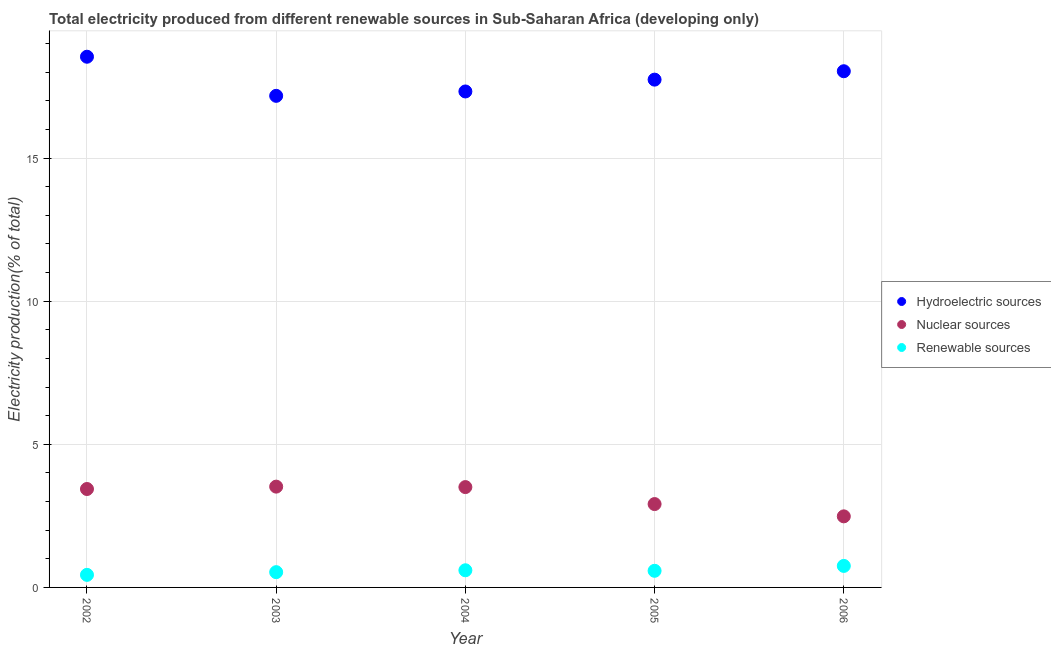What is the percentage of electricity produced by hydroelectric sources in 2005?
Offer a terse response. 17.74. Across all years, what is the maximum percentage of electricity produced by renewable sources?
Provide a succinct answer. 0.75. Across all years, what is the minimum percentage of electricity produced by nuclear sources?
Your answer should be very brief. 2.48. What is the total percentage of electricity produced by hydroelectric sources in the graph?
Keep it short and to the point. 88.81. What is the difference between the percentage of electricity produced by nuclear sources in 2002 and that in 2003?
Provide a short and direct response. -0.08. What is the difference between the percentage of electricity produced by nuclear sources in 2003 and the percentage of electricity produced by renewable sources in 2005?
Offer a very short reply. 2.94. What is the average percentage of electricity produced by hydroelectric sources per year?
Offer a very short reply. 17.76. In the year 2002, what is the difference between the percentage of electricity produced by nuclear sources and percentage of electricity produced by hydroelectric sources?
Offer a very short reply. -15.1. In how many years, is the percentage of electricity produced by renewable sources greater than 7 %?
Keep it short and to the point. 0. What is the ratio of the percentage of electricity produced by renewable sources in 2002 to that in 2006?
Give a very brief answer. 0.58. Is the percentage of electricity produced by renewable sources in 2005 less than that in 2006?
Provide a succinct answer. Yes. What is the difference between the highest and the second highest percentage of electricity produced by renewable sources?
Keep it short and to the point. 0.15. What is the difference between the highest and the lowest percentage of electricity produced by hydroelectric sources?
Ensure brevity in your answer.  1.37. In how many years, is the percentage of electricity produced by hydroelectric sources greater than the average percentage of electricity produced by hydroelectric sources taken over all years?
Ensure brevity in your answer.  2. Is the percentage of electricity produced by hydroelectric sources strictly less than the percentage of electricity produced by renewable sources over the years?
Your answer should be compact. No. How many dotlines are there?
Offer a terse response. 3. What is the difference between two consecutive major ticks on the Y-axis?
Your response must be concise. 5. Does the graph contain any zero values?
Make the answer very short. No. Does the graph contain grids?
Your answer should be compact. Yes. How many legend labels are there?
Offer a very short reply. 3. How are the legend labels stacked?
Provide a succinct answer. Vertical. What is the title of the graph?
Provide a succinct answer. Total electricity produced from different renewable sources in Sub-Saharan Africa (developing only). Does "Food" appear as one of the legend labels in the graph?
Your answer should be compact. No. What is the Electricity production(% of total) of Hydroelectric sources in 2002?
Give a very brief answer. 18.54. What is the Electricity production(% of total) in Nuclear sources in 2002?
Keep it short and to the point. 3.44. What is the Electricity production(% of total) of Renewable sources in 2002?
Give a very brief answer. 0.44. What is the Electricity production(% of total) of Hydroelectric sources in 2003?
Your answer should be very brief. 17.17. What is the Electricity production(% of total) of Nuclear sources in 2003?
Give a very brief answer. 3.52. What is the Electricity production(% of total) in Renewable sources in 2003?
Your response must be concise. 0.53. What is the Electricity production(% of total) of Hydroelectric sources in 2004?
Provide a short and direct response. 17.33. What is the Electricity production(% of total) in Nuclear sources in 2004?
Offer a very short reply. 3.51. What is the Electricity production(% of total) of Renewable sources in 2004?
Your answer should be compact. 0.6. What is the Electricity production(% of total) in Hydroelectric sources in 2005?
Your answer should be very brief. 17.74. What is the Electricity production(% of total) of Nuclear sources in 2005?
Your answer should be compact. 2.91. What is the Electricity production(% of total) in Renewable sources in 2005?
Make the answer very short. 0.58. What is the Electricity production(% of total) in Hydroelectric sources in 2006?
Ensure brevity in your answer.  18.03. What is the Electricity production(% of total) of Nuclear sources in 2006?
Your response must be concise. 2.48. What is the Electricity production(% of total) in Renewable sources in 2006?
Provide a succinct answer. 0.75. Across all years, what is the maximum Electricity production(% of total) in Hydroelectric sources?
Provide a short and direct response. 18.54. Across all years, what is the maximum Electricity production(% of total) of Nuclear sources?
Offer a terse response. 3.52. Across all years, what is the maximum Electricity production(% of total) in Renewable sources?
Give a very brief answer. 0.75. Across all years, what is the minimum Electricity production(% of total) in Hydroelectric sources?
Offer a terse response. 17.17. Across all years, what is the minimum Electricity production(% of total) in Nuclear sources?
Make the answer very short. 2.48. Across all years, what is the minimum Electricity production(% of total) in Renewable sources?
Your response must be concise. 0.44. What is the total Electricity production(% of total) of Hydroelectric sources in the graph?
Keep it short and to the point. 88.81. What is the total Electricity production(% of total) in Nuclear sources in the graph?
Make the answer very short. 15.86. What is the total Electricity production(% of total) of Renewable sources in the graph?
Provide a succinct answer. 2.9. What is the difference between the Electricity production(% of total) in Hydroelectric sources in 2002 and that in 2003?
Provide a succinct answer. 1.37. What is the difference between the Electricity production(% of total) of Nuclear sources in 2002 and that in 2003?
Provide a short and direct response. -0.08. What is the difference between the Electricity production(% of total) of Renewable sources in 2002 and that in 2003?
Give a very brief answer. -0.09. What is the difference between the Electricity production(% of total) in Hydroelectric sources in 2002 and that in 2004?
Make the answer very short. 1.21. What is the difference between the Electricity production(% of total) of Nuclear sources in 2002 and that in 2004?
Provide a succinct answer. -0.07. What is the difference between the Electricity production(% of total) of Renewable sources in 2002 and that in 2004?
Provide a short and direct response. -0.16. What is the difference between the Electricity production(% of total) in Hydroelectric sources in 2002 and that in 2005?
Offer a very short reply. 0.8. What is the difference between the Electricity production(% of total) in Nuclear sources in 2002 and that in 2005?
Give a very brief answer. 0.53. What is the difference between the Electricity production(% of total) of Renewable sources in 2002 and that in 2005?
Offer a terse response. -0.14. What is the difference between the Electricity production(% of total) in Hydroelectric sources in 2002 and that in 2006?
Offer a terse response. 0.51. What is the difference between the Electricity production(% of total) in Nuclear sources in 2002 and that in 2006?
Provide a short and direct response. 0.96. What is the difference between the Electricity production(% of total) in Renewable sources in 2002 and that in 2006?
Keep it short and to the point. -0.31. What is the difference between the Electricity production(% of total) in Hydroelectric sources in 2003 and that in 2004?
Keep it short and to the point. -0.15. What is the difference between the Electricity production(% of total) of Nuclear sources in 2003 and that in 2004?
Ensure brevity in your answer.  0.02. What is the difference between the Electricity production(% of total) in Renewable sources in 2003 and that in 2004?
Provide a succinct answer. -0.07. What is the difference between the Electricity production(% of total) in Hydroelectric sources in 2003 and that in 2005?
Keep it short and to the point. -0.57. What is the difference between the Electricity production(% of total) in Nuclear sources in 2003 and that in 2005?
Your answer should be very brief. 0.61. What is the difference between the Electricity production(% of total) in Renewable sources in 2003 and that in 2005?
Keep it short and to the point. -0.05. What is the difference between the Electricity production(% of total) in Hydroelectric sources in 2003 and that in 2006?
Provide a succinct answer. -0.86. What is the difference between the Electricity production(% of total) of Nuclear sources in 2003 and that in 2006?
Your response must be concise. 1.04. What is the difference between the Electricity production(% of total) in Renewable sources in 2003 and that in 2006?
Offer a very short reply. -0.22. What is the difference between the Electricity production(% of total) in Hydroelectric sources in 2004 and that in 2005?
Keep it short and to the point. -0.41. What is the difference between the Electricity production(% of total) of Nuclear sources in 2004 and that in 2005?
Your answer should be compact. 0.59. What is the difference between the Electricity production(% of total) in Renewable sources in 2004 and that in 2005?
Your answer should be compact. 0.02. What is the difference between the Electricity production(% of total) in Hydroelectric sources in 2004 and that in 2006?
Make the answer very short. -0.71. What is the difference between the Electricity production(% of total) of Nuclear sources in 2004 and that in 2006?
Offer a terse response. 1.02. What is the difference between the Electricity production(% of total) in Renewable sources in 2004 and that in 2006?
Ensure brevity in your answer.  -0.15. What is the difference between the Electricity production(% of total) of Hydroelectric sources in 2005 and that in 2006?
Make the answer very short. -0.29. What is the difference between the Electricity production(% of total) in Nuclear sources in 2005 and that in 2006?
Offer a very short reply. 0.43. What is the difference between the Electricity production(% of total) in Renewable sources in 2005 and that in 2006?
Offer a very short reply. -0.17. What is the difference between the Electricity production(% of total) of Hydroelectric sources in 2002 and the Electricity production(% of total) of Nuclear sources in 2003?
Offer a terse response. 15.02. What is the difference between the Electricity production(% of total) of Hydroelectric sources in 2002 and the Electricity production(% of total) of Renewable sources in 2003?
Your response must be concise. 18. What is the difference between the Electricity production(% of total) of Nuclear sources in 2002 and the Electricity production(% of total) of Renewable sources in 2003?
Your answer should be compact. 2.9. What is the difference between the Electricity production(% of total) in Hydroelectric sources in 2002 and the Electricity production(% of total) in Nuclear sources in 2004?
Offer a very short reply. 15.03. What is the difference between the Electricity production(% of total) in Hydroelectric sources in 2002 and the Electricity production(% of total) in Renewable sources in 2004?
Ensure brevity in your answer.  17.94. What is the difference between the Electricity production(% of total) of Nuclear sources in 2002 and the Electricity production(% of total) of Renewable sources in 2004?
Your answer should be compact. 2.84. What is the difference between the Electricity production(% of total) of Hydroelectric sources in 2002 and the Electricity production(% of total) of Nuclear sources in 2005?
Keep it short and to the point. 15.63. What is the difference between the Electricity production(% of total) of Hydroelectric sources in 2002 and the Electricity production(% of total) of Renewable sources in 2005?
Your response must be concise. 17.96. What is the difference between the Electricity production(% of total) in Nuclear sources in 2002 and the Electricity production(% of total) in Renewable sources in 2005?
Your response must be concise. 2.86. What is the difference between the Electricity production(% of total) in Hydroelectric sources in 2002 and the Electricity production(% of total) in Nuclear sources in 2006?
Your answer should be compact. 16.06. What is the difference between the Electricity production(% of total) of Hydroelectric sources in 2002 and the Electricity production(% of total) of Renewable sources in 2006?
Offer a terse response. 17.79. What is the difference between the Electricity production(% of total) of Nuclear sources in 2002 and the Electricity production(% of total) of Renewable sources in 2006?
Give a very brief answer. 2.69. What is the difference between the Electricity production(% of total) of Hydroelectric sources in 2003 and the Electricity production(% of total) of Nuclear sources in 2004?
Ensure brevity in your answer.  13.67. What is the difference between the Electricity production(% of total) in Hydroelectric sources in 2003 and the Electricity production(% of total) in Renewable sources in 2004?
Offer a terse response. 16.57. What is the difference between the Electricity production(% of total) in Nuclear sources in 2003 and the Electricity production(% of total) in Renewable sources in 2004?
Provide a short and direct response. 2.92. What is the difference between the Electricity production(% of total) of Hydroelectric sources in 2003 and the Electricity production(% of total) of Nuclear sources in 2005?
Give a very brief answer. 14.26. What is the difference between the Electricity production(% of total) in Hydroelectric sources in 2003 and the Electricity production(% of total) in Renewable sources in 2005?
Your response must be concise. 16.59. What is the difference between the Electricity production(% of total) of Nuclear sources in 2003 and the Electricity production(% of total) of Renewable sources in 2005?
Make the answer very short. 2.94. What is the difference between the Electricity production(% of total) of Hydroelectric sources in 2003 and the Electricity production(% of total) of Nuclear sources in 2006?
Provide a succinct answer. 14.69. What is the difference between the Electricity production(% of total) in Hydroelectric sources in 2003 and the Electricity production(% of total) in Renewable sources in 2006?
Offer a terse response. 16.42. What is the difference between the Electricity production(% of total) in Nuclear sources in 2003 and the Electricity production(% of total) in Renewable sources in 2006?
Provide a succinct answer. 2.77. What is the difference between the Electricity production(% of total) in Hydroelectric sources in 2004 and the Electricity production(% of total) in Nuclear sources in 2005?
Keep it short and to the point. 14.41. What is the difference between the Electricity production(% of total) in Hydroelectric sources in 2004 and the Electricity production(% of total) in Renewable sources in 2005?
Your answer should be very brief. 16.74. What is the difference between the Electricity production(% of total) in Nuclear sources in 2004 and the Electricity production(% of total) in Renewable sources in 2005?
Ensure brevity in your answer.  2.92. What is the difference between the Electricity production(% of total) in Hydroelectric sources in 2004 and the Electricity production(% of total) in Nuclear sources in 2006?
Provide a succinct answer. 14.84. What is the difference between the Electricity production(% of total) in Hydroelectric sources in 2004 and the Electricity production(% of total) in Renewable sources in 2006?
Provide a succinct answer. 16.57. What is the difference between the Electricity production(% of total) of Nuclear sources in 2004 and the Electricity production(% of total) of Renewable sources in 2006?
Offer a very short reply. 2.75. What is the difference between the Electricity production(% of total) in Hydroelectric sources in 2005 and the Electricity production(% of total) in Nuclear sources in 2006?
Provide a succinct answer. 15.26. What is the difference between the Electricity production(% of total) of Hydroelectric sources in 2005 and the Electricity production(% of total) of Renewable sources in 2006?
Your answer should be compact. 16.99. What is the difference between the Electricity production(% of total) of Nuclear sources in 2005 and the Electricity production(% of total) of Renewable sources in 2006?
Provide a short and direct response. 2.16. What is the average Electricity production(% of total) in Hydroelectric sources per year?
Your answer should be very brief. 17.76. What is the average Electricity production(% of total) in Nuclear sources per year?
Your answer should be compact. 3.17. What is the average Electricity production(% of total) of Renewable sources per year?
Keep it short and to the point. 0.58. In the year 2002, what is the difference between the Electricity production(% of total) in Hydroelectric sources and Electricity production(% of total) in Nuclear sources?
Give a very brief answer. 15.1. In the year 2002, what is the difference between the Electricity production(% of total) in Hydroelectric sources and Electricity production(% of total) in Renewable sources?
Provide a succinct answer. 18.1. In the year 2002, what is the difference between the Electricity production(% of total) of Nuclear sources and Electricity production(% of total) of Renewable sources?
Provide a short and direct response. 3. In the year 2003, what is the difference between the Electricity production(% of total) of Hydroelectric sources and Electricity production(% of total) of Nuclear sources?
Offer a very short reply. 13.65. In the year 2003, what is the difference between the Electricity production(% of total) in Hydroelectric sources and Electricity production(% of total) in Renewable sources?
Offer a terse response. 16.64. In the year 2003, what is the difference between the Electricity production(% of total) in Nuclear sources and Electricity production(% of total) in Renewable sources?
Offer a very short reply. 2.99. In the year 2004, what is the difference between the Electricity production(% of total) in Hydroelectric sources and Electricity production(% of total) in Nuclear sources?
Your response must be concise. 13.82. In the year 2004, what is the difference between the Electricity production(% of total) in Hydroelectric sources and Electricity production(% of total) in Renewable sources?
Your answer should be very brief. 16.73. In the year 2004, what is the difference between the Electricity production(% of total) in Nuclear sources and Electricity production(% of total) in Renewable sources?
Your answer should be very brief. 2.91. In the year 2005, what is the difference between the Electricity production(% of total) in Hydroelectric sources and Electricity production(% of total) in Nuclear sources?
Offer a very short reply. 14.83. In the year 2005, what is the difference between the Electricity production(% of total) of Hydroelectric sources and Electricity production(% of total) of Renewable sources?
Offer a very short reply. 17.16. In the year 2005, what is the difference between the Electricity production(% of total) of Nuclear sources and Electricity production(% of total) of Renewable sources?
Give a very brief answer. 2.33. In the year 2006, what is the difference between the Electricity production(% of total) in Hydroelectric sources and Electricity production(% of total) in Nuclear sources?
Provide a succinct answer. 15.55. In the year 2006, what is the difference between the Electricity production(% of total) of Hydroelectric sources and Electricity production(% of total) of Renewable sources?
Make the answer very short. 17.28. In the year 2006, what is the difference between the Electricity production(% of total) in Nuclear sources and Electricity production(% of total) in Renewable sources?
Keep it short and to the point. 1.73. What is the ratio of the Electricity production(% of total) of Hydroelectric sources in 2002 to that in 2003?
Provide a short and direct response. 1.08. What is the ratio of the Electricity production(% of total) of Nuclear sources in 2002 to that in 2003?
Offer a very short reply. 0.98. What is the ratio of the Electricity production(% of total) of Renewable sources in 2002 to that in 2003?
Your answer should be compact. 0.82. What is the ratio of the Electricity production(% of total) in Hydroelectric sources in 2002 to that in 2004?
Offer a very short reply. 1.07. What is the ratio of the Electricity production(% of total) of Nuclear sources in 2002 to that in 2004?
Offer a very short reply. 0.98. What is the ratio of the Electricity production(% of total) of Renewable sources in 2002 to that in 2004?
Your answer should be compact. 0.73. What is the ratio of the Electricity production(% of total) of Hydroelectric sources in 2002 to that in 2005?
Provide a short and direct response. 1.05. What is the ratio of the Electricity production(% of total) of Nuclear sources in 2002 to that in 2005?
Provide a short and direct response. 1.18. What is the ratio of the Electricity production(% of total) of Renewable sources in 2002 to that in 2005?
Offer a very short reply. 0.76. What is the ratio of the Electricity production(% of total) in Hydroelectric sources in 2002 to that in 2006?
Keep it short and to the point. 1.03. What is the ratio of the Electricity production(% of total) of Nuclear sources in 2002 to that in 2006?
Your answer should be very brief. 1.38. What is the ratio of the Electricity production(% of total) of Renewable sources in 2002 to that in 2006?
Offer a terse response. 0.58. What is the ratio of the Electricity production(% of total) of Hydroelectric sources in 2003 to that in 2004?
Offer a terse response. 0.99. What is the ratio of the Electricity production(% of total) in Nuclear sources in 2003 to that in 2004?
Keep it short and to the point. 1. What is the ratio of the Electricity production(% of total) of Renewable sources in 2003 to that in 2004?
Offer a very short reply. 0.89. What is the ratio of the Electricity production(% of total) in Hydroelectric sources in 2003 to that in 2005?
Provide a succinct answer. 0.97. What is the ratio of the Electricity production(% of total) of Nuclear sources in 2003 to that in 2005?
Offer a terse response. 1.21. What is the ratio of the Electricity production(% of total) of Renewable sources in 2003 to that in 2005?
Your answer should be very brief. 0.92. What is the ratio of the Electricity production(% of total) in Hydroelectric sources in 2003 to that in 2006?
Keep it short and to the point. 0.95. What is the ratio of the Electricity production(% of total) of Nuclear sources in 2003 to that in 2006?
Your answer should be very brief. 1.42. What is the ratio of the Electricity production(% of total) of Renewable sources in 2003 to that in 2006?
Provide a short and direct response. 0.71. What is the ratio of the Electricity production(% of total) of Hydroelectric sources in 2004 to that in 2005?
Ensure brevity in your answer.  0.98. What is the ratio of the Electricity production(% of total) in Nuclear sources in 2004 to that in 2005?
Provide a short and direct response. 1.2. What is the ratio of the Electricity production(% of total) of Renewable sources in 2004 to that in 2005?
Ensure brevity in your answer.  1.03. What is the ratio of the Electricity production(% of total) in Hydroelectric sources in 2004 to that in 2006?
Give a very brief answer. 0.96. What is the ratio of the Electricity production(% of total) of Nuclear sources in 2004 to that in 2006?
Offer a very short reply. 1.41. What is the ratio of the Electricity production(% of total) of Renewable sources in 2004 to that in 2006?
Your response must be concise. 0.8. What is the ratio of the Electricity production(% of total) in Hydroelectric sources in 2005 to that in 2006?
Give a very brief answer. 0.98. What is the ratio of the Electricity production(% of total) in Nuclear sources in 2005 to that in 2006?
Make the answer very short. 1.17. What is the ratio of the Electricity production(% of total) of Renewable sources in 2005 to that in 2006?
Your answer should be very brief. 0.77. What is the difference between the highest and the second highest Electricity production(% of total) of Hydroelectric sources?
Provide a short and direct response. 0.51. What is the difference between the highest and the second highest Electricity production(% of total) of Nuclear sources?
Offer a very short reply. 0.02. What is the difference between the highest and the second highest Electricity production(% of total) in Renewable sources?
Keep it short and to the point. 0.15. What is the difference between the highest and the lowest Electricity production(% of total) of Hydroelectric sources?
Keep it short and to the point. 1.37. What is the difference between the highest and the lowest Electricity production(% of total) of Nuclear sources?
Your answer should be compact. 1.04. What is the difference between the highest and the lowest Electricity production(% of total) in Renewable sources?
Offer a terse response. 0.31. 